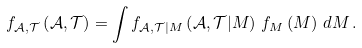Convert formula to latex. <formula><loc_0><loc_0><loc_500><loc_500>f _ { \mathcal { A } , \mathcal { T } } \left ( \mathcal { A } , \mathcal { T } \right ) = \int f _ { \mathcal { A } , \mathcal { T } | M } \left ( \mathcal { A } , \mathcal { T } | M \right ) \, f _ { M } \left ( M \right ) \, d M \, .</formula> 